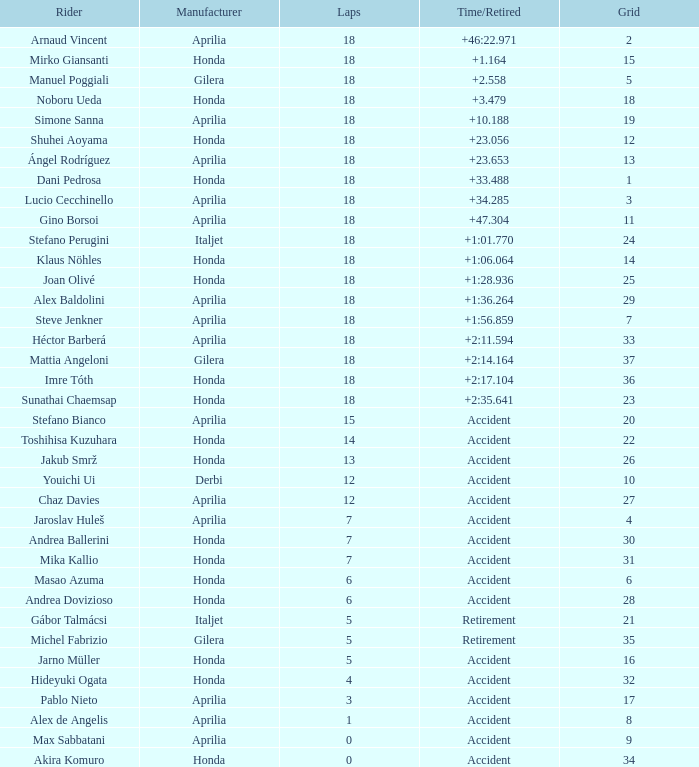What is the time/retired of the honda manufacturer with a grid less than 26, 18 laps, and joan olivé as the rider? +1:28.936. 